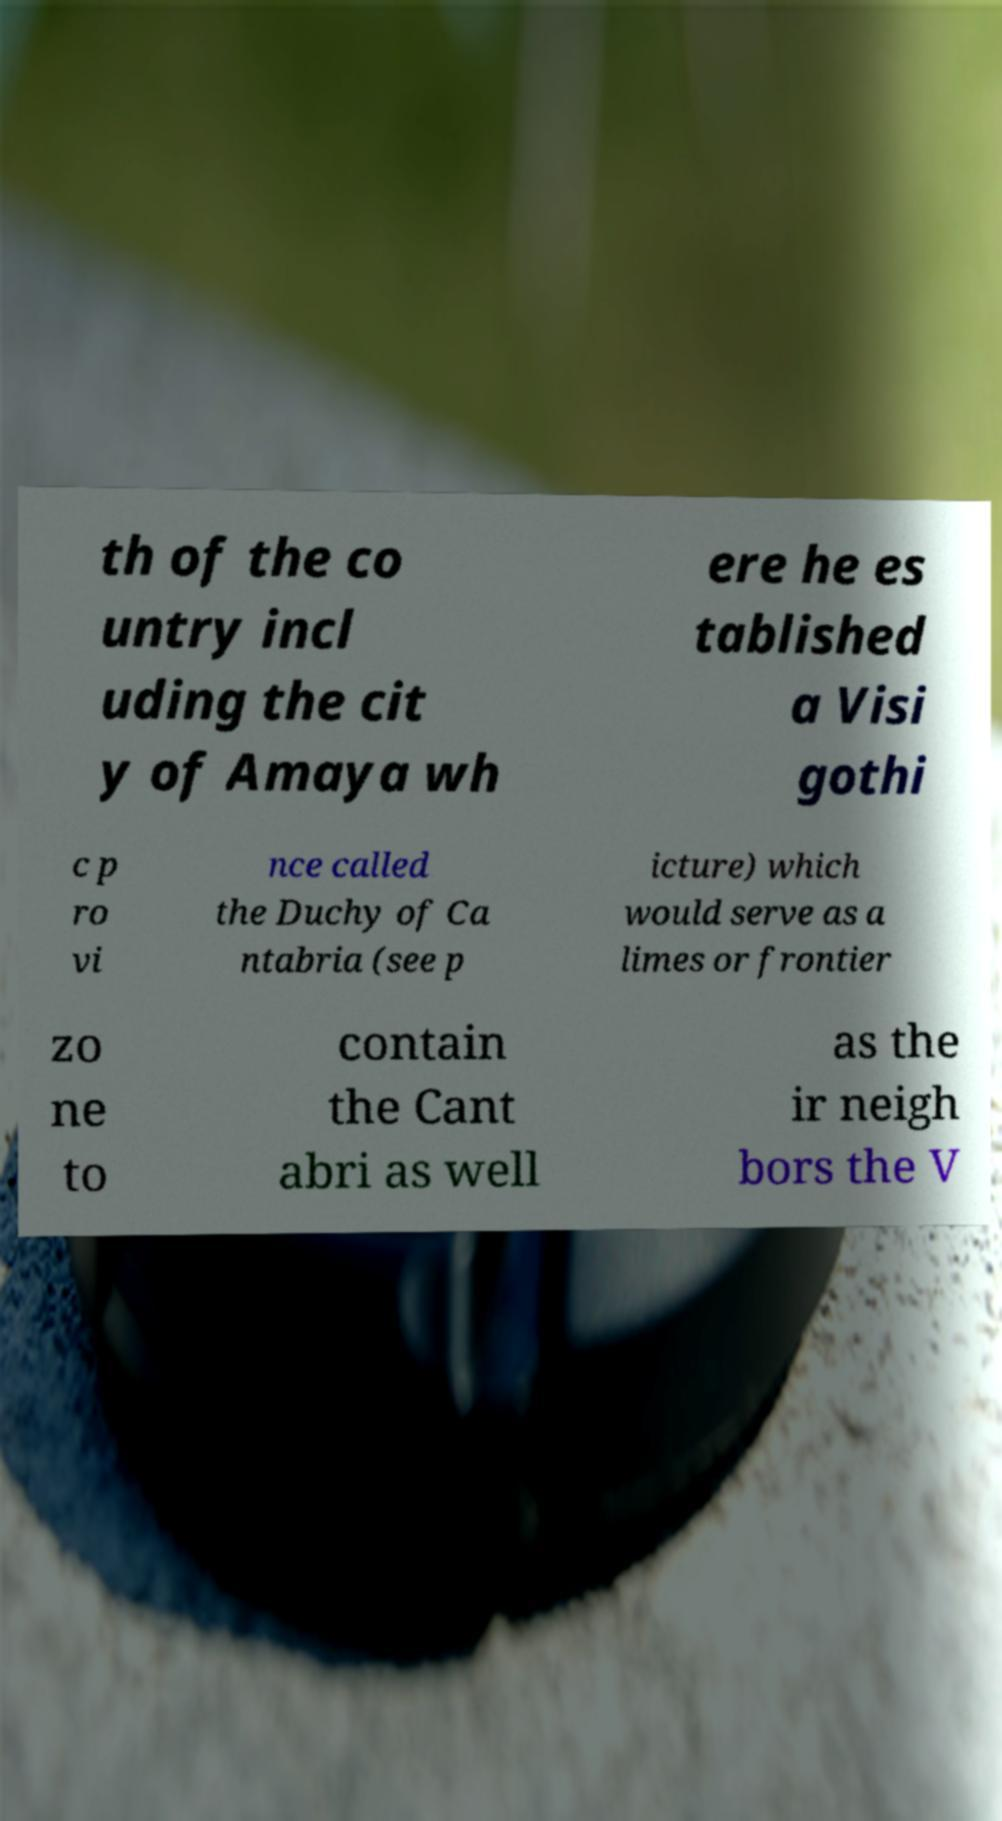Please identify and transcribe the text found in this image. th of the co untry incl uding the cit y of Amaya wh ere he es tablished a Visi gothi c p ro vi nce called the Duchy of Ca ntabria (see p icture) which would serve as a limes or frontier zo ne to contain the Cant abri as well as the ir neigh bors the V 